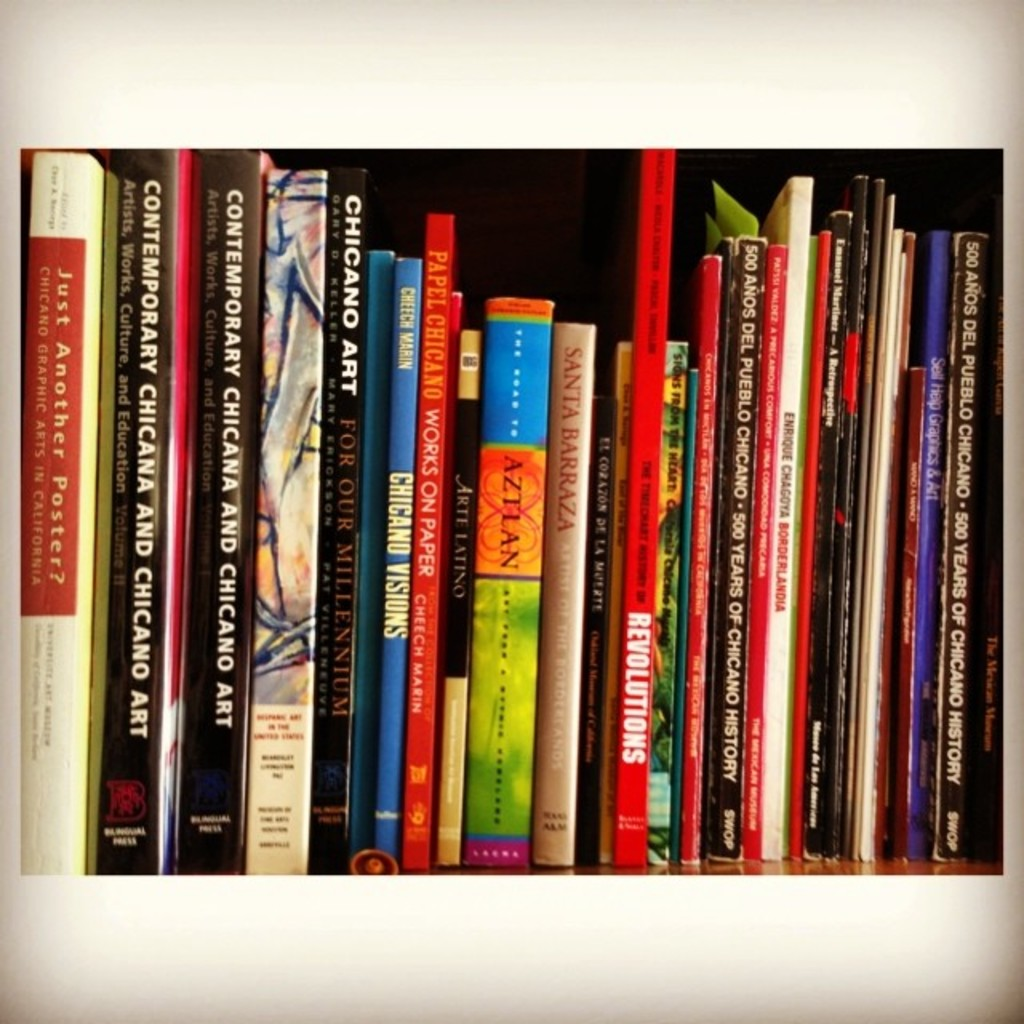What can you infer about the owner's interests from the books visible in the image? The owner appears to have a keen interest in art, culture, and history, particularly related to Chicago, indicating a deep appreciation for regional cultural expressions and possibly an academic or personal passion for these subjects. 